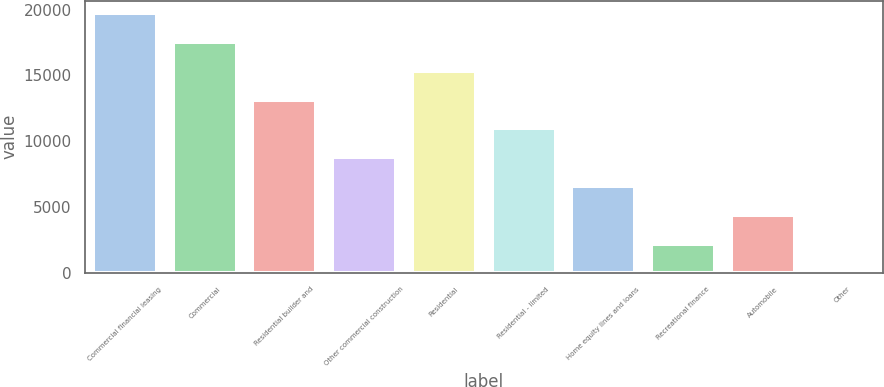Convert chart. <chart><loc_0><loc_0><loc_500><loc_500><bar_chart><fcel>Commercial financial leasing<fcel>Commercial<fcel>Residential builder and<fcel>Other commercial construction<fcel>Residential<fcel>Residential - limited<fcel>Home equity lines and loans<fcel>Recreational finance<fcel>Automobile<fcel>Other<nl><fcel>19699.9<fcel>17514.8<fcel>13144.6<fcel>8774.4<fcel>15329.7<fcel>10959.5<fcel>6589.3<fcel>2219.1<fcel>4404.2<fcel>34<nl></chart> 